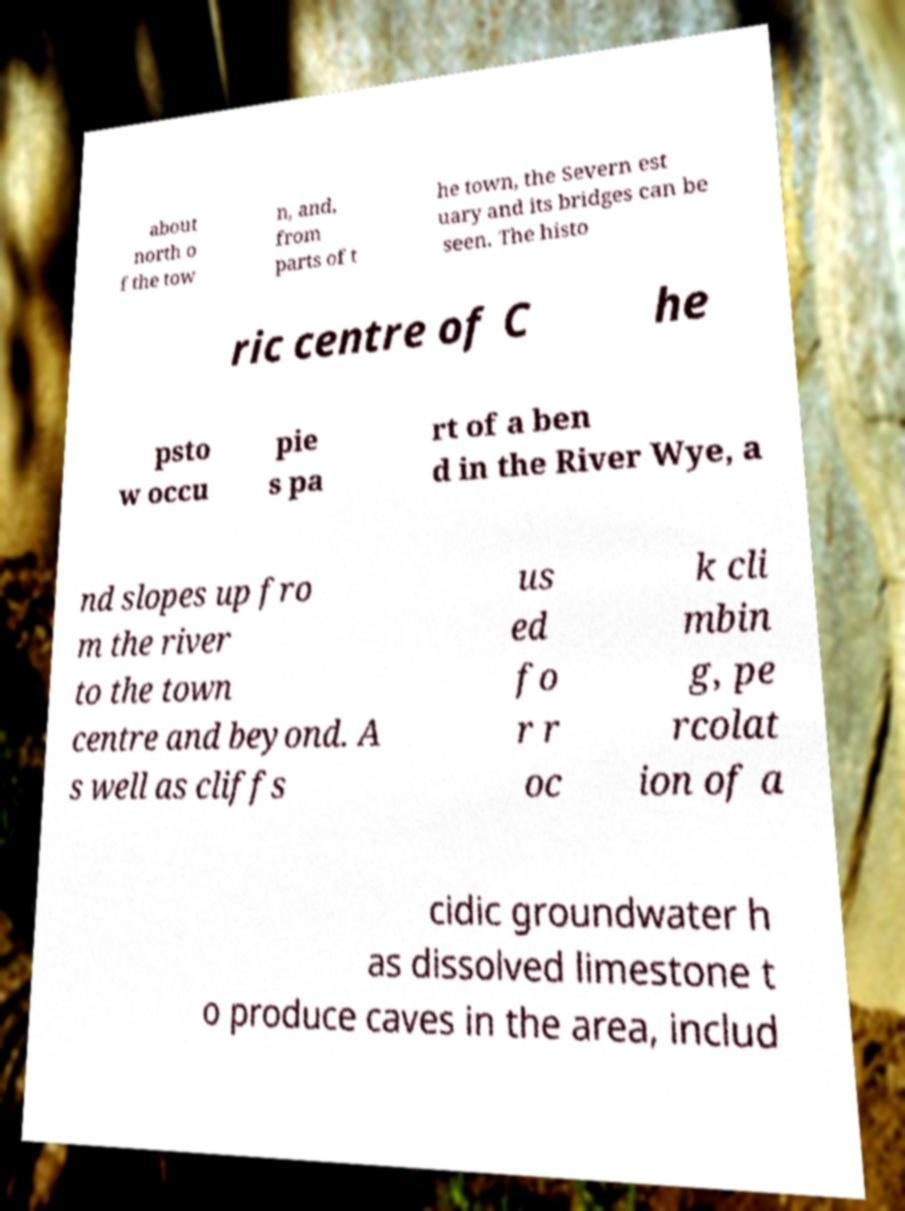Can you accurately transcribe the text from the provided image for me? about north o f the tow n, and, from parts of t he town, the Severn est uary and its bridges can be seen. The histo ric centre of C he psto w occu pie s pa rt of a ben d in the River Wye, a nd slopes up fro m the river to the town centre and beyond. A s well as cliffs us ed fo r r oc k cli mbin g, pe rcolat ion of a cidic groundwater h as dissolved limestone t o produce caves in the area, includ 